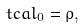Convert formula to latex. <formula><loc_0><loc_0><loc_500><loc_500>\ t c a l _ { 0 } = { \rho } ,</formula> 